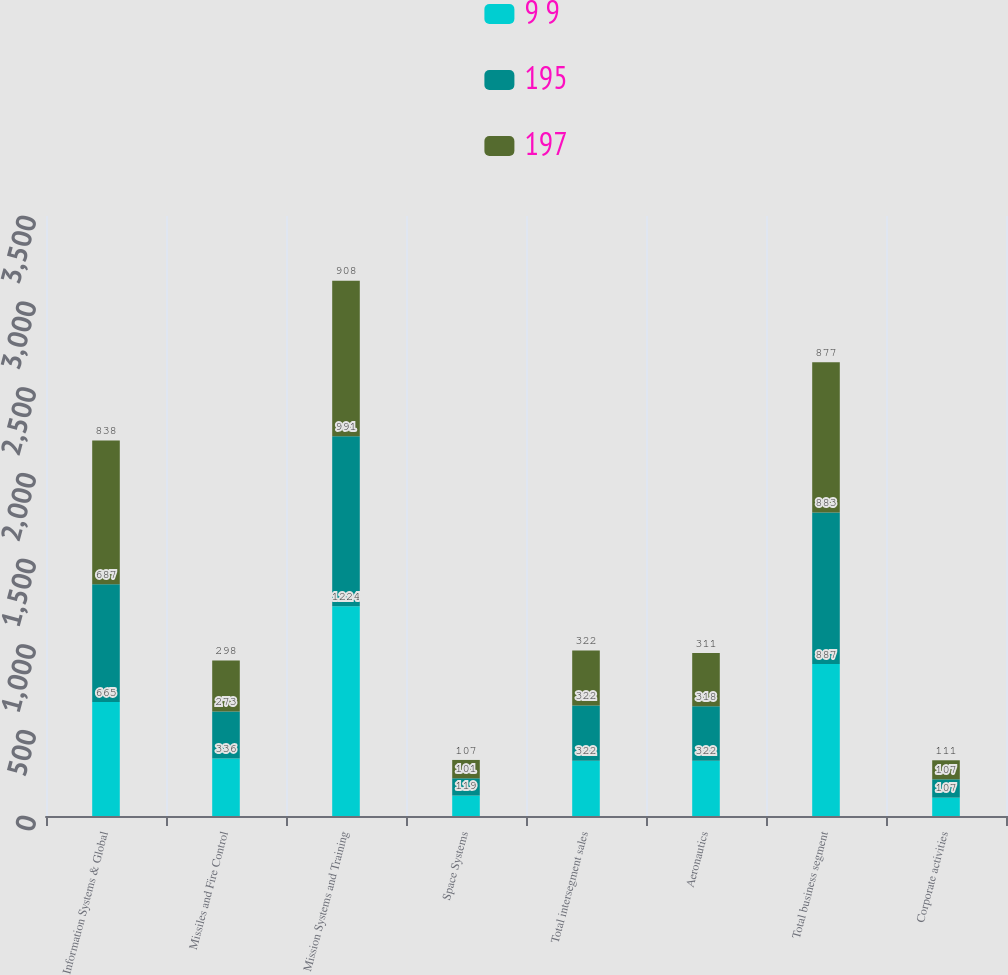Convert chart to OTSL. <chart><loc_0><loc_0><loc_500><loc_500><stacked_bar_chart><ecel><fcel>Information Systems & Global<fcel>Missiles and Fire Control<fcel>Mission Systems and Training<fcel>Space Systems<fcel>Total intersegment sales<fcel>Aeronautics<fcel>Total business segment<fcel>Corporate activities<nl><fcel>9 9<fcel>665<fcel>336<fcel>1224<fcel>119<fcel>322<fcel>322<fcel>887<fcel>107<nl><fcel>195<fcel>687<fcel>273<fcel>991<fcel>101<fcel>322<fcel>318<fcel>883<fcel>107<nl><fcel>197<fcel>838<fcel>298<fcel>908<fcel>107<fcel>322<fcel>311<fcel>877<fcel>111<nl></chart> 